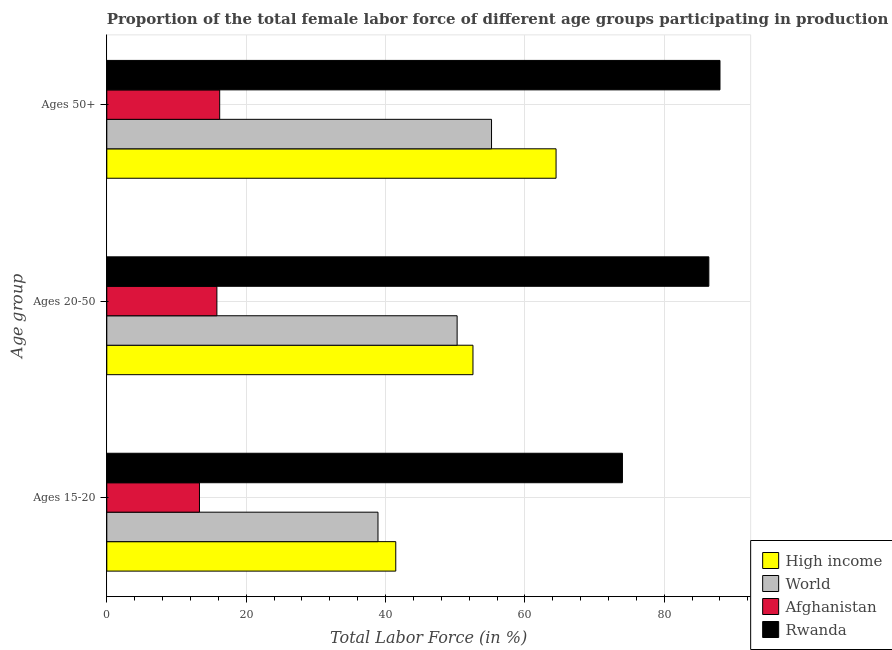Are the number of bars per tick equal to the number of legend labels?
Provide a short and direct response. Yes. How many bars are there on the 1st tick from the top?
Ensure brevity in your answer.  4. How many bars are there on the 1st tick from the bottom?
Your response must be concise. 4. What is the label of the 1st group of bars from the top?
Keep it short and to the point. Ages 50+. What is the percentage of female labor force above age 50 in High income?
Provide a succinct answer. 64.47. Across all countries, what is the minimum percentage of female labor force within the age group 20-50?
Your answer should be very brief. 15.8. In which country was the percentage of female labor force within the age group 20-50 maximum?
Your response must be concise. Rwanda. In which country was the percentage of female labor force within the age group 20-50 minimum?
Provide a succinct answer. Afghanistan. What is the total percentage of female labor force within the age group 15-20 in the graph?
Make the answer very short. 167.69. What is the difference between the percentage of female labor force above age 50 in High income and that in Rwanda?
Ensure brevity in your answer.  -23.53. What is the difference between the percentage of female labor force within the age group 20-50 in Rwanda and the percentage of female labor force within the age group 15-20 in Afghanistan?
Your answer should be compact. 73.1. What is the average percentage of female labor force within the age group 20-50 per country?
Provide a succinct answer. 51.26. What is the difference between the percentage of female labor force above age 50 and percentage of female labor force within the age group 20-50 in Afghanistan?
Provide a succinct answer. 0.4. In how many countries, is the percentage of female labor force within the age group 15-20 greater than 24 %?
Offer a terse response. 3. What is the ratio of the percentage of female labor force above age 50 in Rwanda to that in High income?
Make the answer very short. 1.36. Is the percentage of female labor force within the age group 15-20 in Rwanda less than that in Afghanistan?
Provide a succinct answer. No. What is the difference between the highest and the second highest percentage of female labor force above age 50?
Offer a very short reply. 23.53. What is the difference between the highest and the lowest percentage of female labor force within the age group 20-50?
Your response must be concise. 70.6. In how many countries, is the percentage of female labor force within the age group 15-20 greater than the average percentage of female labor force within the age group 15-20 taken over all countries?
Ensure brevity in your answer.  1. Is the sum of the percentage of female labor force above age 50 in Rwanda and Afghanistan greater than the maximum percentage of female labor force within the age group 15-20 across all countries?
Offer a very short reply. Yes. What does the 4th bar from the bottom in Ages 20-50 represents?
Provide a short and direct response. Rwanda. Is it the case that in every country, the sum of the percentage of female labor force within the age group 15-20 and percentage of female labor force within the age group 20-50 is greater than the percentage of female labor force above age 50?
Provide a short and direct response. Yes. Are the values on the major ticks of X-axis written in scientific E-notation?
Ensure brevity in your answer.  No. Does the graph contain grids?
Provide a succinct answer. Yes. How many legend labels are there?
Your answer should be very brief. 4. How are the legend labels stacked?
Your answer should be compact. Vertical. What is the title of the graph?
Offer a very short reply. Proportion of the total female labor force of different age groups participating in production in 2013. Does "Israel" appear as one of the legend labels in the graph?
Offer a terse response. No. What is the label or title of the Y-axis?
Offer a terse response. Age group. What is the Total Labor Force (in %) in High income in Ages 15-20?
Your answer should be compact. 41.47. What is the Total Labor Force (in %) of World in Ages 15-20?
Provide a succinct answer. 38.92. What is the Total Labor Force (in %) of Afghanistan in Ages 15-20?
Your answer should be very brief. 13.3. What is the Total Labor Force (in %) of High income in Ages 20-50?
Provide a succinct answer. 52.55. What is the Total Labor Force (in %) in World in Ages 20-50?
Offer a terse response. 50.28. What is the Total Labor Force (in %) of Afghanistan in Ages 20-50?
Your answer should be very brief. 15.8. What is the Total Labor Force (in %) in Rwanda in Ages 20-50?
Provide a short and direct response. 86.4. What is the Total Labor Force (in %) in High income in Ages 50+?
Offer a very short reply. 64.47. What is the Total Labor Force (in %) of World in Ages 50+?
Give a very brief answer. 55.21. What is the Total Labor Force (in %) in Afghanistan in Ages 50+?
Offer a very short reply. 16.2. What is the Total Labor Force (in %) in Rwanda in Ages 50+?
Your response must be concise. 88. Across all Age group, what is the maximum Total Labor Force (in %) of High income?
Make the answer very short. 64.47. Across all Age group, what is the maximum Total Labor Force (in %) of World?
Offer a terse response. 55.21. Across all Age group, what is the maximum Total Labor Force (in %) in Afghanistan?
Your answer should be compact. 16.2. Across all Age group, what is the minimum Total Labor Force (in %) in High income?
Make the answer very short. 41.47. Across all Age group, what is the minimum Total Labor Force (in %) in World?
Provide a succinct answer. 38.92. Across all Age group, what is the minimum Total Labor Force (in %) of Afghanistan?
Keep it short and to the point. 13.3. What is the total Total Labor Force (in %) of High income in the graph?
Provide a succinct answer. 158.5. What is the total Total Labor Force (in %) in World in the graph?
Offer a very short reply. 144.41. What is the total Total Labor Force (in %) of Afghanistan in the graph?
Your answer should be compact. 45.3. What is the total Total Labor Force (in %) of Rwanda in the graph?
Give a very brief answer. 248.4. What is the difference between the Total Labor Force (in %) of High income in Ages 15-20 and that in Ages 20-50?
Offer a terse response. -11.08. What is the difference between the Total Labor Force (in %) in World in Ages 15-20 and that in Ages 20-50?
Your answer should be very brief. -11.36. What is the difference between the Total Labor Force (in %) of Afghanistan in Ages 15-20 and that in Ages 20-50?
Ensure brevity in your answer.  -2.5. What is the difference between the Total Labor Force (in %) of Rwanda in Ages 15-20 and that in Ages 20-50?
Keep it short and to the point. -12.4. What is the difference between the Total Labor Force (in %) of High income in Ages 15-20 and that in Ages 50+?
Your answer should be very brief. -23. What is the difference between the Total Labor Force (in %) in World in Ages 15-20 and that in Ages 50+?
Your answer should be compact. -16.3. What is the difference between the Total Labor Force (in %) in Rwanda in Ages 15-20 and that in Ages 50+?
Keep it short and to the point. -14. What is the difference between the Total Labor Force (in %) in High income in Ages 20-50 and that in Ages 50+?
Provide a succinct answer. -11.92. What is the difference between the Total Labor Force (in %) of World in Ages 20-50 and that in Ages 50+?
Offer a terse response. -4.94. What is the difference between the Total Labor Force (in %) of Afghanistan in Ages 20-50 and that in Ages 50+?
Make the answer very short. -0.4. What is the difference between the Total Labor Force (in %) of High income in Ages 15-20 and the Total Labor Force (in %) of World in Ages 20-50?
Give a very brief answer. -8.81. What is the difference between the Total Labor Force (in %) of High income in Ages 15-20 and the Total Labor Force (in %) of Afghanistan in Ages 20-50?
Your answer should be very brief. 25.67. What is the difference between the Total Labor Force (in %) of High income in Ages 15-20 and the Total Labor Force (in %) of Rwanda in Ages 20-50?
Keep it short and to the point. -44.93. What is the difference between the Total Labor Force (in %) of World in Ages 15-20 and the Total Labor Force (in %) of Afghanistan in Ages 20-50?
Keep it short and to the point. 23.12. What is the difference between the Total Labor Force (in %) of World in Ages 15-20 and the Total Labor Force (in %) of Rwanda in Ages 20-50?
Keep it short and to the point. -47.48. What is the difference between the Total Labor Force (in %) of Afghanistan in Ages 15-20 and the Total Labor Force (in %) of Rwanda in Ages 20-50?
Provide a succinct answer. -73.1. What is the difference between the Total Labor Force (in %) in High income in Ages 15-20 and the Total Labor Force (in %) in World in Ages 50+?
Make the answer very short. -13.74. What is the difference between the Total Labor Force (in %) of High income in Ages 15-20 and the Total Labor Force (in %) of Afghanistan in Ages 50+?
Keep it short and to the point. 25.27. What is the difference between the Total Labor Force (in %) in High income in Ages 15-20 and the Total Labor Force (in %) in Rwanda in Ages 50+?
Offer a very short reply. -46.53. What is the difference between the Total Labor Force (in %) in World in Ages 15-20 and the Total Labor Force (in %) in Afghanistan in Ages 50+?
Provide a succinct answer. 22.72. What is the difference between the Total Labor Force (in %) of World in Ages 15-20 and the Total Labor Force (in %) of Rwanda in Ages 50+?
Make the answer very short. -49.08. What is the difference between the Total Labor Force (in %) in Afghanistan in Ages 15-20 and the Total Labor Force (in %) in Rwanda in Ages 50+?
Make the answer very short. -74.7. What is the difference between the Total Labor Force (in %) of High income in Ages 20-50 and the Total Labor Force (in %) of World in Ages 50+?
Ensure brevity in your answer.  -2.66. What is the difference between the Total Labor Force (in %) in High income in Ages 20-50 and the Total Labor Force (in %) in Afghanistan in Ages 50+?
Ensure brevity in your answer.  36.35. What is the difference between the Total Labor Force (in %) in High income in Ages 20-50 and the Total Labor Force (in %) in Rwanda in Ages 50+?
Offer a very short reply. -35.45. What is the difference between the Total Labor Force (in %) of World in Ages 20-50 and the Total Labor Force (in %) of Afghanistan in Ages 50+?
Offer a very short reply. 34.08. What is the difference between the Total Labor Force (in %) of World in Ages 20-50 and the Total Labor Force (in %) of Rwanda in Ages 50+?
Provide a succinct answer. -37.72. What is the difference between the Total Labor Force (in %) in Afghanistan in Ages 20-50 and the Total Labor Force (in %) in Rwanda in Ages 50+?
Your response must be concise. -72.2. What is the average Total Labor Force (in %) of High income per Age group?
Offer a terse response. 52.83. What is the average Total Labor Force (in %) in World per Age group?
Ensure brevity in your answer.  48.14. What is the average Total Labor Force (in %) in Rwanda per Age group?
Ensure brevity in your answer.  82.8. What is the difference between the Total Labor Force (in %) of High income and Total Labor Force (in %) of World in Ages 15-20?
Make the answer very short. 2.55. What is the difference between the Total Labor Force (in %) of High income and Total Labor Force (in %) of Afghanistan in Ages 15-20?
Offer a terse response. 28.17. What is the difference between the Total Labor Force (in %) in High income and Total Labor Force (in %) in Rwanda in Ages 15-20?
Provide a succinct answer. -32.53. What is the difference between the Total Labor Force (in %) in World and Total Labor Force (in %) in Afghanistan in Ages 15-20?
Your answer should be compact. 25.62. What is the difference between the Total Labor Force (in %) of World and Total Labor Force (in %) of Rwanda in Ages 15-20?
Provide a succinct answer. -35.08. What is the difference between the Total Labor Force (in %) of Afghanistan and Total Labor Force (in %) of Rwanda in Ages 15-20?
Offer a terse response. -60.7. What is the difference between the Total Labor Force (in %) of High income and Total Labor Force (in %) of World in Ages 20-50?
Ensure brevity in your answer.  2.27. What is the difference between the Total Labor Force (in %) of High income and Total Labor Force (in %) of Afghanistan in Ages 20-50?
Offer a very short reply. 36.75. What is the difference between the Total Labor Force (in %) of High income and Total Labor Force (in %) of Rwanda in Ages 20-50?
Provide a short and direct response. -33.85. What is the difference between the Total Labor Force (in %) in World and Total Labor Force (in %) in Afghanistan in Ages 20-50?
Give a very brief answer. 34.48. What is the difference between the Total Labor Force (in %) in World and Total Labor Force (in %) in Rwanda in Ages 20-50?
Keep it short and to the point. -36.12. What is the difference between the Total Labor Force (in %) in Afghanistan and Total Labor Force (in %) in Rwanda in Ages 20-50?
Your answer should be very brief. -70.6. What is the difference between the Total Labor Force (in %) of High income and Total Labor Force (in %) of World in Ages 50+?
Ensure brevity in your answer.  9.26. What is the difference between the Total Labor Force (in %) of High income and Total Labor Force (in %) of Afghanistan in Ages 50+?
Your answer should be very brief. 48.27. What is the difference between the Total Labor Force (in %) of High income and Total Labor Force (in %) of Rwanda in Ages 50+?
Offer a very short reply. -23.53. What is the difference between the Total Labor Force (in %) of World and Total Labor Force (in %) of Afghanistan in Ages 50+?
Your response must be concise. 39.01. What is the difference between the Total Labor Force (in %) in World and Total Labor Force (in %) in Rwanda in Ages 50+?
Offer a very short reply. -32.79. What is the difference between the Total Labor Force (in %) of Afghanistan and Total Labor Force (in %) of Rwanda in Ages 50+?
Make the answer very short. -71.8. What is the ratio of the Total Labor Force (in %) of High income in Ages 15-20 to that in Ages 20-50?
Keep it short and to the point. 0.79. What is the ratio of the Total Labor Force (in %) of World in Ages 15-20 to that in Ages 20-50?
Offer a very short reply. 0.77. What is the ratio of the Total Labor Force (in %) in Afghanistan in Ages 15-20 to that in Ages 20-50?
Give a very brief answer. 0.84. What is the ratio of the Total Labor Force (in %) of Rwanda in Ages 15-20 to that in Ages 20-50?
Your response must be concise. 0.86. What is the ratio of the Total Labor Force (in %) in High income in Ages 15-20 to that in Ages 50+?
Your answer should be compact. 0.64. What is the ratio of the Total Labor Force (in %) in World in Ages 15-20 to that in Ages 50+?
Make the answer very short. 0.7. What is the ratio of the Total Labor Force (in %) in Afghanistan in Ages 15-20 to that in Ages 50+?
Offer a very short reply. 0.82. What is the ratio of the Total Labor Force (in %) of Rwanda in Ages 15-20 to that in Ages 50+?
Make the answer very short. 0.84. What is the ratio of the Total Labor Force (in %) in High income in Ages 20-50 to that in Ages 50+?
Ensure brevity in your answer.  0.81. What is the ratio of the Total Labor Force (in %) in World in Ages 20-50 to that in Ages 50+?
Your answer should be compact. 0.91. What is the ratio of the Total Labor Force (in %) of Afghanistan in Ages 20-50 to that in Ages 50+?
Give a very brief answer. 0.98. What is the ratio of the Total Labor Force (in %) of Rwanda in Ages 20-50 to that in Ages 50+?
Provide a short and direct response. 0.98. What is the difference between the highest and the second highest Total Labor Force (in %) of High income?
Your answer should be compact. 11.92. What is the difference between the highest and the second highest Total Labor Force (in %) in World?
Offer a very short reply. 4.94. What is the difference between the highest and the second highest Total Labor Force (in %) of Afghanistan?
Provide a succinct answer. 0.4. What is the difference between the highest and the second highest Total Labor Force (in %) in Rwanda?
Your answer should be very brief. 1.6. What is the difference between the highest and the lowest Total Labor Force (in %) of High income?
Provide a succinct answer. 23. What is the difference between the highest and the lowest Total Labor Force (in %) of World?
Your answer should be very brief. 16.3. What is the difference between the highest and the lowest Total Labor Force (in %) in Afghanistan?
Make the answer very short. 2.9. 